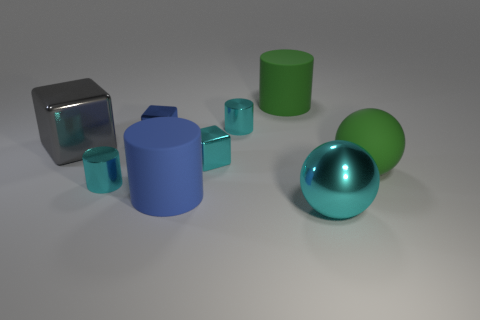Subtract 1 cylinders. How many cylinders are left? 3 Subtract all brown cylinders. Subtract all cyan blocks. How many cylinders are left? 4 Add 1 tiny blue shiny blocks. How many objects exist? 10 Subtract all cubes. How many objects are left? 6 Add 7 brown cylinders. How many brown cylinders exist? 7 Subtract 0 brown spheres. How many objects are left? 9 Subtract all cylinders. Subtract all large blue matte things. How many objects are left? 4 Add 4 large gray metallic objects. How many large gray metallic objects are left? 5 